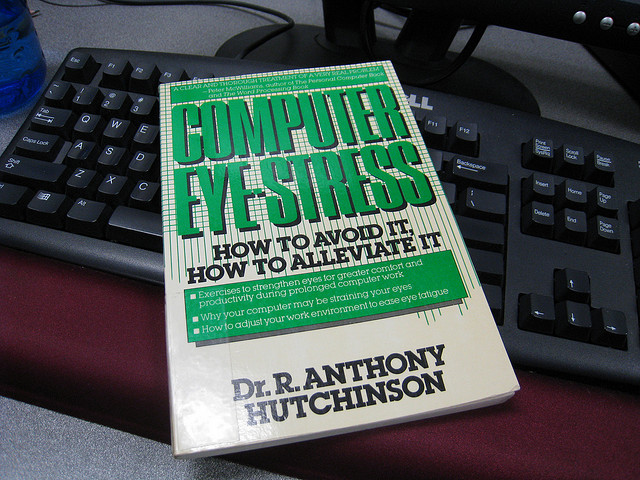Extract all visible text content from this image. COMPUTER EYE STRESS HOW TO AVOID P17 C S D E W O A x Z productivity your adjust How computer Your work may prolonged be straining 10 environment your computer work eues ease elangue and comfort greater 105 eyes strengthen 10 Exercises Dr.R.ANTHONY HUTCHINSON IT ALLEVIATE TO IT 